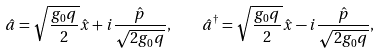<formula> <loc_0><loc_0><loc_500><loc_500>\hat { a } = \sqrt { \frac { g _ { 0 } q } { 2 } } \hat { x } + i \frac { \hat { p } } { \sqrt { 2 g _ { 0 } q } } , \quad \hat { a } ^ { \dagger } = \sqrt { \frac { g _ { 0 } q } { 2 } } \hat { x } - i \frac { \hat { p } } { \sqrt { 2 g _ { 0 } q } } ,</formula> 